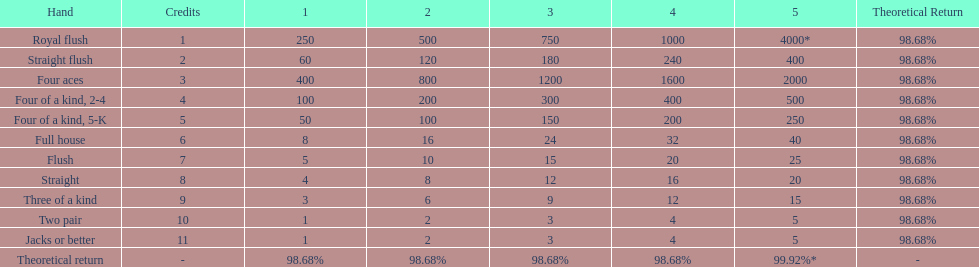What's the best type of four of a kind to win? Four of a kind, 2-4. 